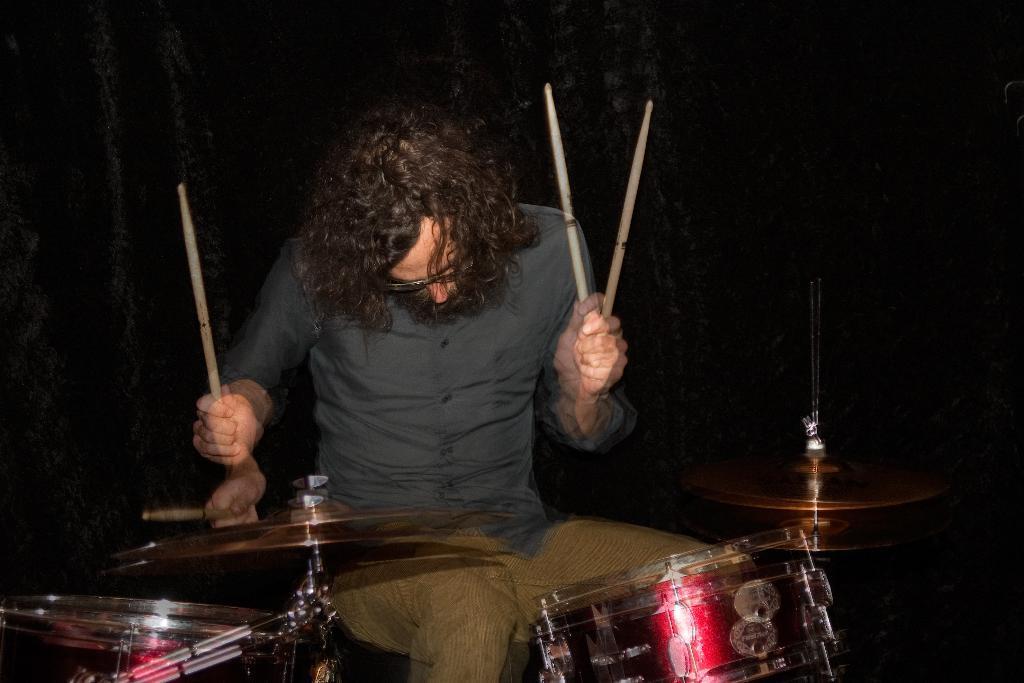Please provide a concise description of this image. In this image there is a man who is playing the drums with the sticks. 